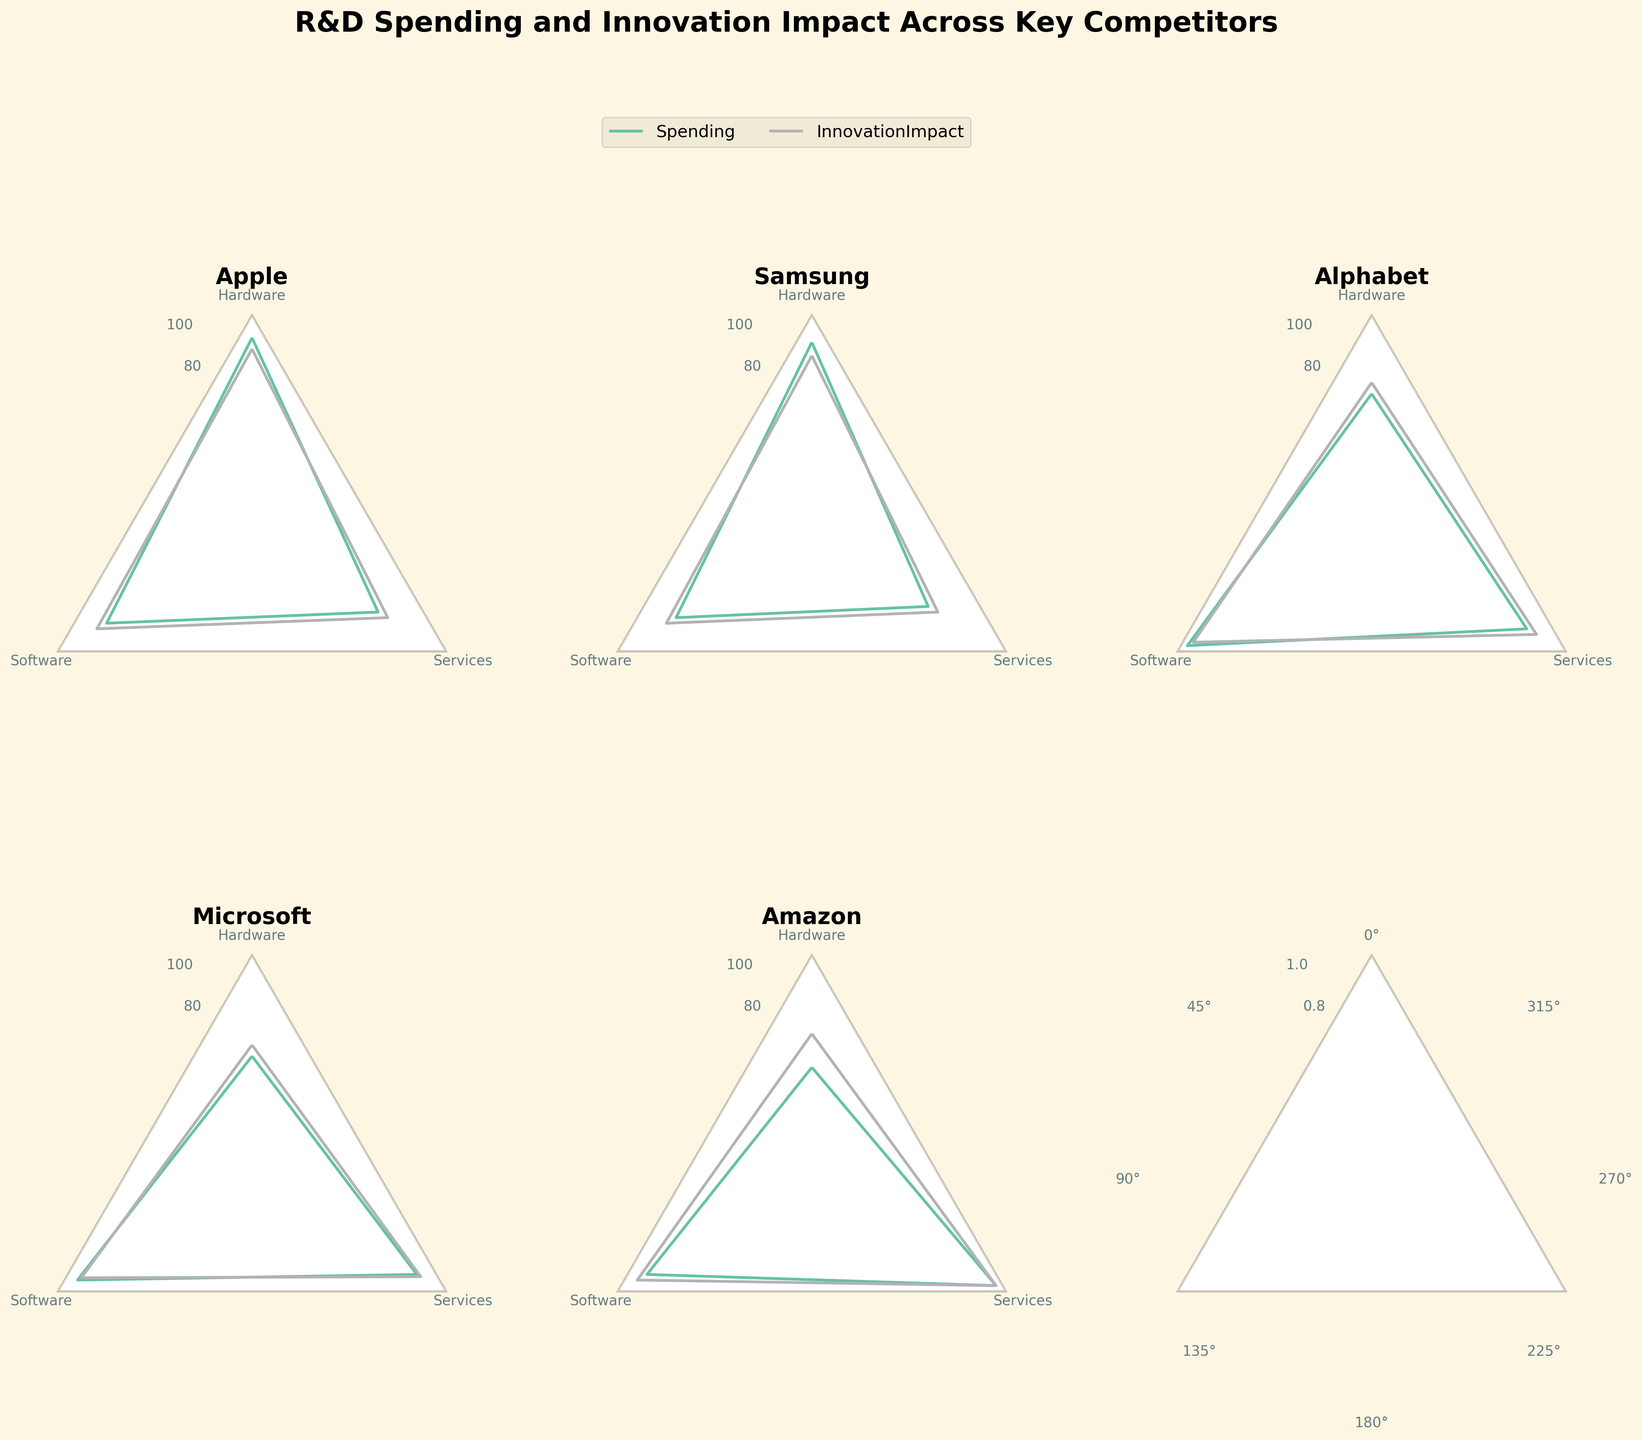What is the title of this figure? The title is usually positioned prominently at the top of the figure. It is written in bold to be easily noticeable.
Answer: R&D Spending and Innovation Impact Across Key Competitors How many companies are represented in this radar chart figure? By counting the unique subplot titles which represent different companies, we can see there are 5 companies.
Answer: 5 Which company has the highest spending on Services? In the radar chart, you can compare the values plotted for "Spending" for the "Services" category across different companies. Amazon's plot shows the highest value.
Answer: Amazon What is the general trend between Spending and Innovation Impact across companies? By observing the radar plots for each company, it's apparent that higher R&D spending tends to correlate with higher Innovation Impact.
Answer: Higher spending tends to correlate with higher innovation impact Which company shows the greatest difference between Spending in Hardware and Software? Comparing the respective points for "Spending" in Hardware and Software categories for each company, Alphabet shows a significant difference where Software spending is much higher than Hardware.
Answer: Alphabet Out of Amazon and Microsoft, which company has a greater average Innovation Impact across all categories? First, calculate the average of Innovation Impact values for each company's three categories. For Amazon: (65 + 90 + 95)/3 = 83.33. For Microsoft: (60 + 88 + 87)/3 = 78.33.
Answer: Amazon Which company has the most balanced R&D spending across all categories? By inspecting the radar charts, the company showing the smallest variation among categories will be the most balanced. Alphabet shows relatively balanced spending as the values are closer in magnitude.
Answer: Alphabet Does spending in Hardware correlate more strongly with Innovation Impact than spending in Software across all companies? Compare the shapes of the plots for Hardware and Innovation Impact to those of Software and Innovation Impact. Hardware aligns more closely in several companies like Apple and Samsung.
Answer: Yes What trend do you observe in the Services category across all companies? By comparing the radar plots, we notice that the spending and innovation impact in the Services category is generally lower than other categories except for Microsoft and Amazon.
Answer: Generally lower Which two companies have the closest Innovation Impact in the Software category? By looking at the values in the Software section for Innovation Impact, Microsoft and Alphabet have very close values at 88 and 92, respectively.
Answer: Microsoft and Alphabet 